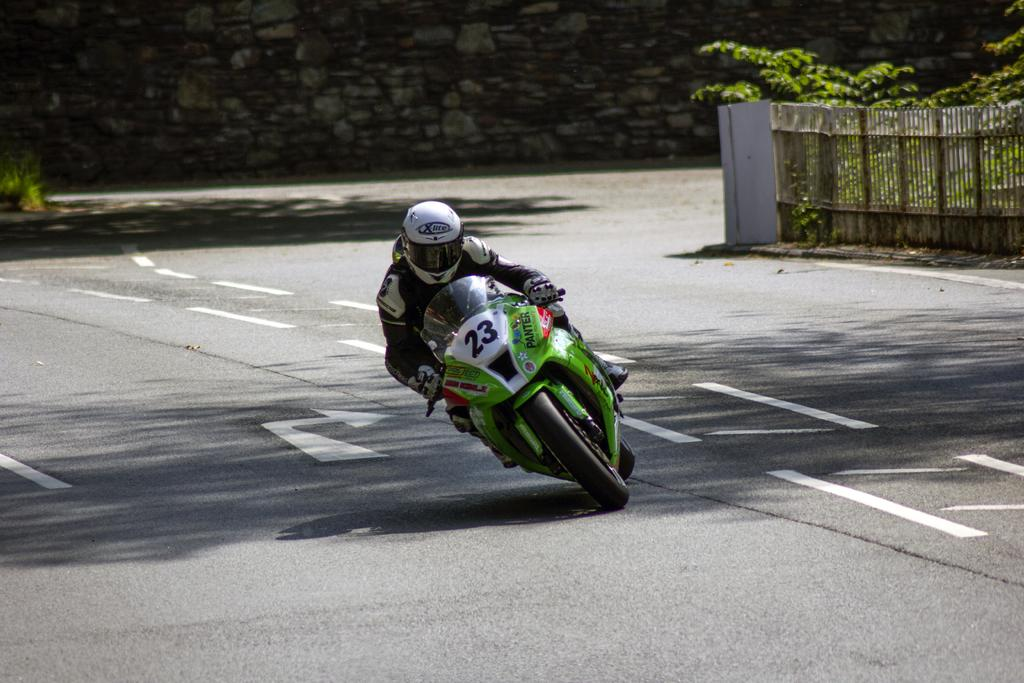What is the person in the image doing? There is a person riding a motorcycle in the image. Where is the person riding the motorcycle? The person is on a road. What can be seen in the background of the image? There is a fence, trees, and a wall in the background of the image. How many toys are scattered on the road in the image? There are no toys present in the image; it features a person riding a motorcycle on a road with a background of a fence, trees, and a wall. 